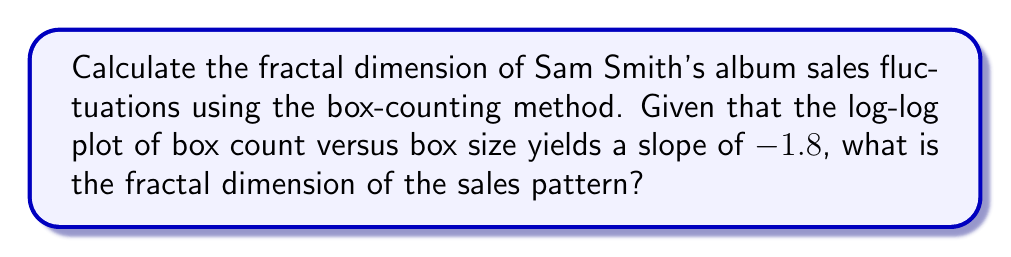Show me your answer to this math problem. To calculate the fractal dimension using the box-counting method, we follow these steps:

1. The box-counting method involves covering the fractal pattern with boxes of different sizes and counting how many boxes are needed to cover the pattern at each size.

2. We plot the logarithm of the number of boxes against the logarithm of the box size.

3. The slope of this log-log plot is related to the fractal dimension.

4. The fractal dimension $D$ is given by the negative of the slope:

   $$D = -\text{slope}$$

5. In this case, we're given that the slope of the log-log plot is -1.8.

6. Therefore, the fractal dimension is:

   $$D = -(-1.8) = 1.8$$

This fractal dimension of 1.8 suggests that the album sales fluctuations for Sam Smith's discography have a complex, self-similar structure that falls between a line (dimension 1) and a plane (dimension 2), indicating a highly intricate pattern of sales variations across different time scales.
Answer: $1.8$ 